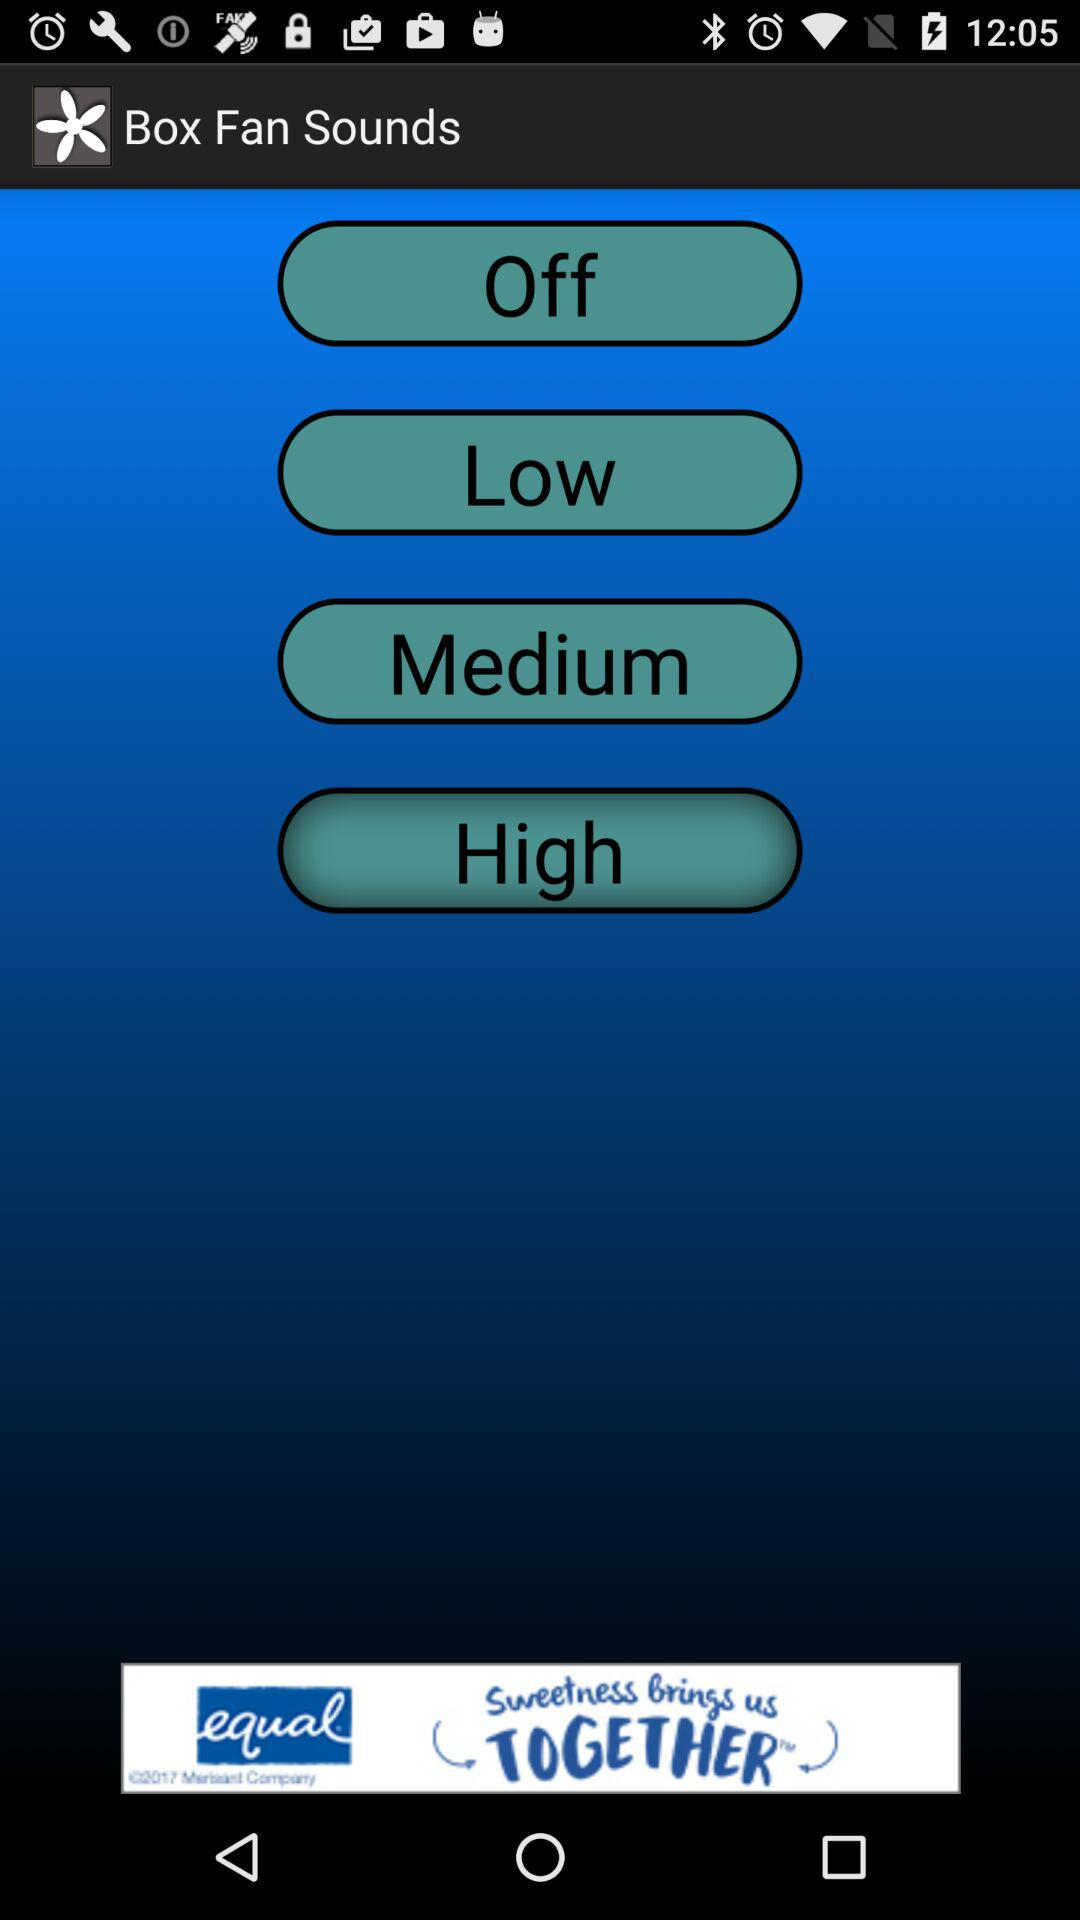What is the application name? The application name is "Box Fan Sounds". 